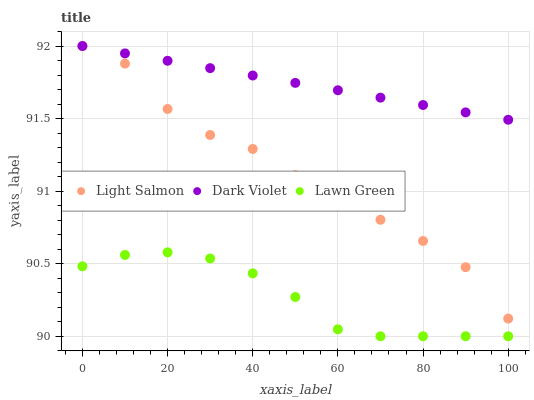Does Lawn Green have the minimum area under the curve?
Answer yes or no. Yes. Does Dark Violet have the maximum area under the curve?
Answer yes or no. Yes. Does Light Salmon have the minimum area under the curve?
Answer yes or no. No. Does Light Salmon have the maximum area under the curve?
Answer yes or no. No. Is Dark Violet the smoothest?
Answer yes or no. Yes. Is Light Salmon the roughest?
Answer yes or no. Yes. Is Light Salmon the smoothest?
Answer yes or no. No. Is Dark Violet the roughest?
Answer yes or no. No. Does Lawn Green have the lowest value?
Answer yes or no. Yes. Does Light Salmon have the lowest value?
Answer yes or no. No. Does Dark Violet have the highest value?
Answer yes or no. Yes. Is Lawn Green less than Light Salmon?
Answer yes or no. Yes. Is Light Salmon greater than Lawn Green?
Answer yes or no. Yes. Does Light Salmon intersect Dark Violet?
Answer yes or no. Yes. Is Light Salmon less than Dark Violet?
Answer yes or no. No. Is Light Salmon greater than Dark Violet?
Answer yes or no. No. Does Lawn Green intersect Light Salmon?
Answer yes or no. No. 